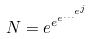<formula> <loc_0><loc_0><loc_500><loc_500>N = e ^ { e ^ { e ^ { \dots ^ { e ^ { j } } } } }</formula> 